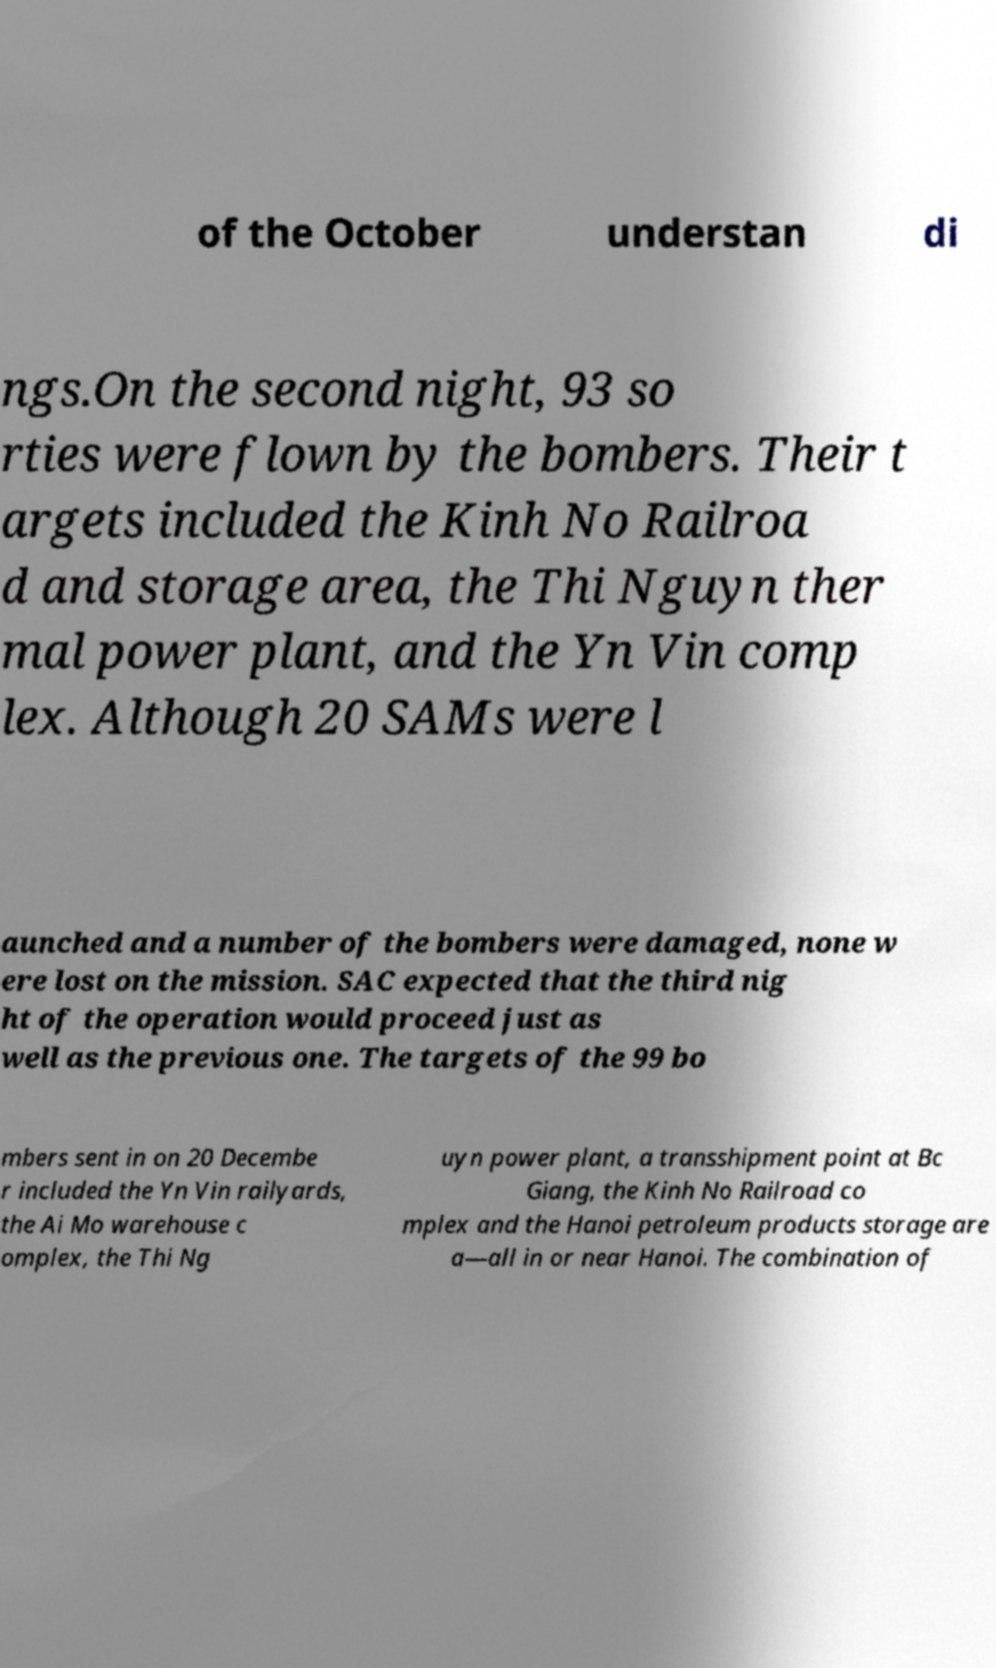Could you assist in decoding the text presented in this image and type it out clearly? of the October understan di ngs.On the second night, 93 so rties were flown by the bombers. Their t argets included the Kinh No Railroa d and storage area, the Thi Nguyn ther mal power plant, and the Yn Vin comp lex. Although 20 SAMs were l aunched and a number of the bombers were damaged, none w ere lost on the mission. SAC expected that the third nig ht of the operation would proceed just as well as the previous one. The targets of the 99 bo mbers sent in on 20 Decembe r included the Yn Vin railyards, the Ai Mo warehouse c omplex, the Thi Ng uyn power plant, a transshipment point at Bc Giang, the Kinh No Railroad co mplex and the Hanoi petroleum products storage are a—all in or near Hanoi. The combination of 